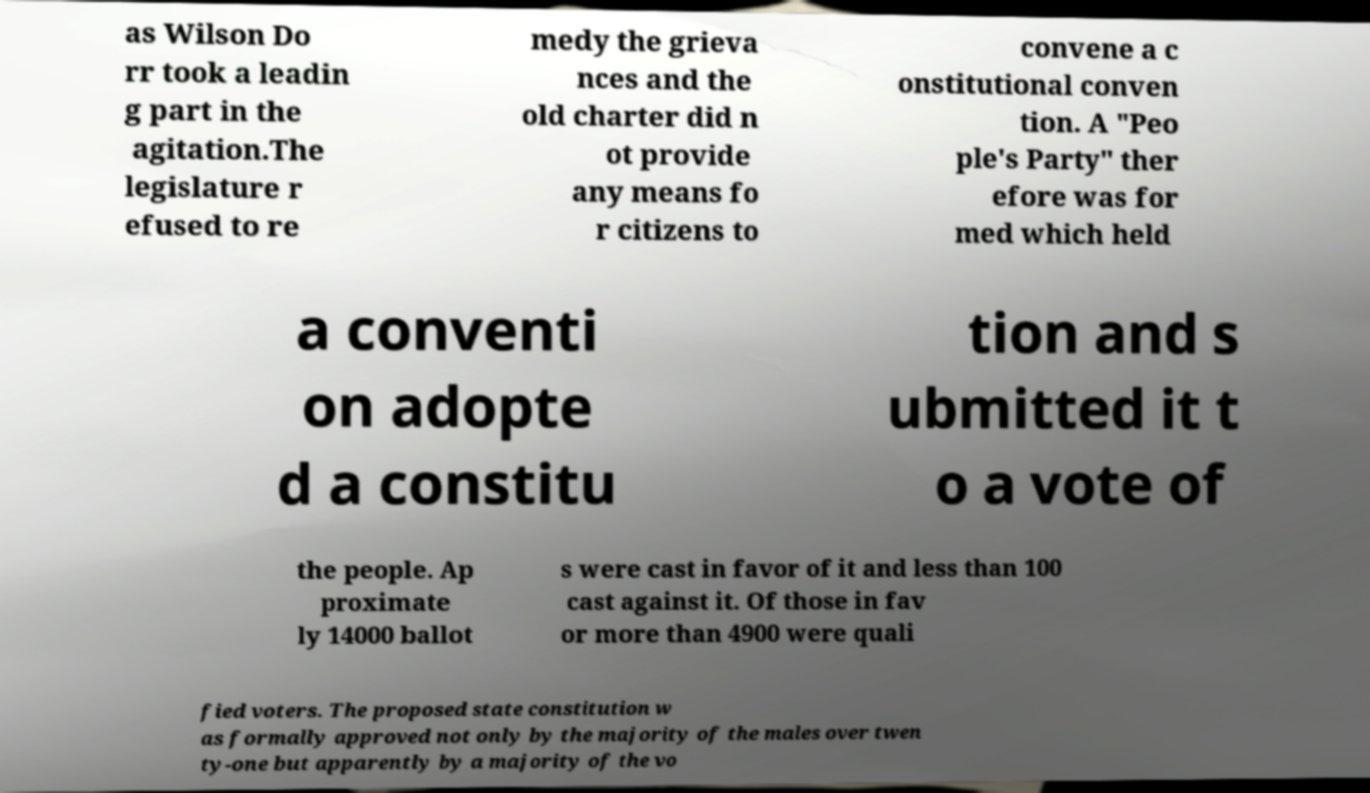Please identify and transcribe the text found in this image. as Wilson Do rr took a leadin g part in the agitation.The legislature r efused to re medy the grieva nces and the old charter did n ot provide any means fo r citizens to convene a c onstitutional conven tion. A "Peo ple's Party" ther efore was for med which held a conventi on adopte d a constitu tion and s ubmitted it t o a vote of the people. Ap proximate ly 14000 ballot s were cast in favor of it and less than 100 cast against it. Of those in fav or more than 4900 were quali fied voters. The proposed state constitution w as formally approved not only by the majority of the males over twen ty-one but apparently by a majority of the vo 